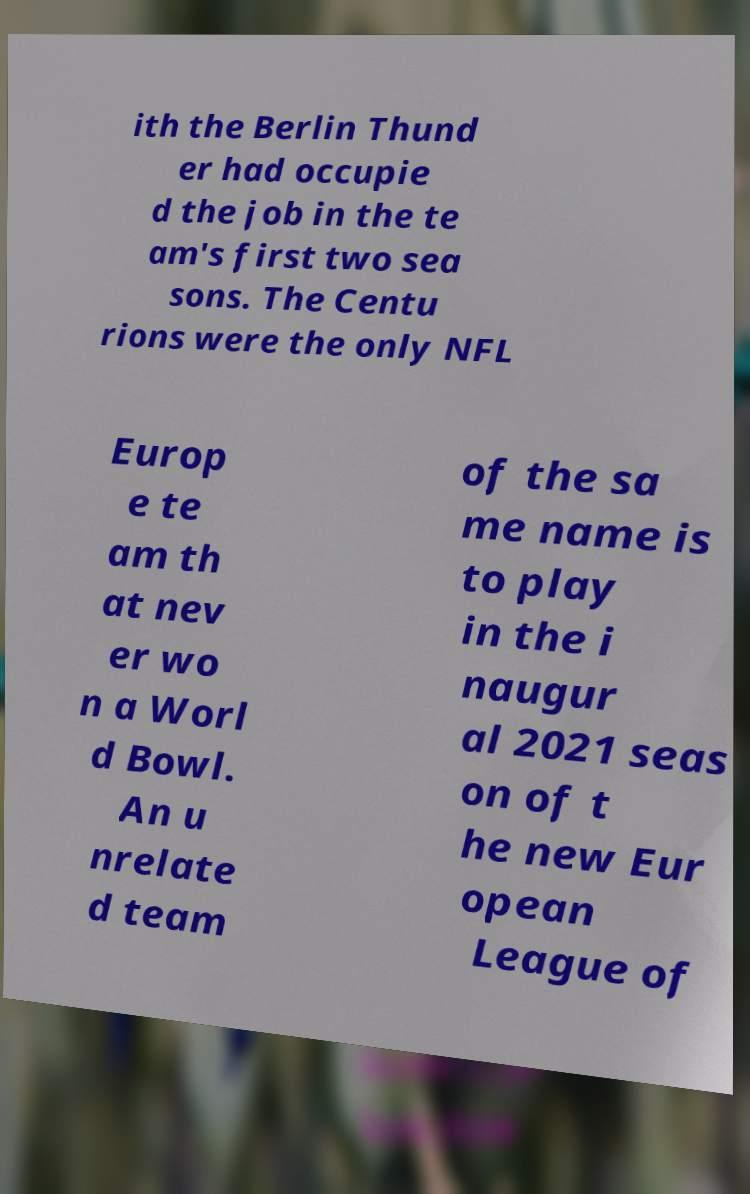Please identify and transcribe the text found in this image. ith the Berlin Thund er had occupie d the job in the te am's first two sea sons. The Centu rions were the only NFL Europ e te am th at nev er wo n a Worl d Bowl. An u nrelate d team of the sa me name is to play in the i naugur al 2021 seas on of t he new Eur opean League of 